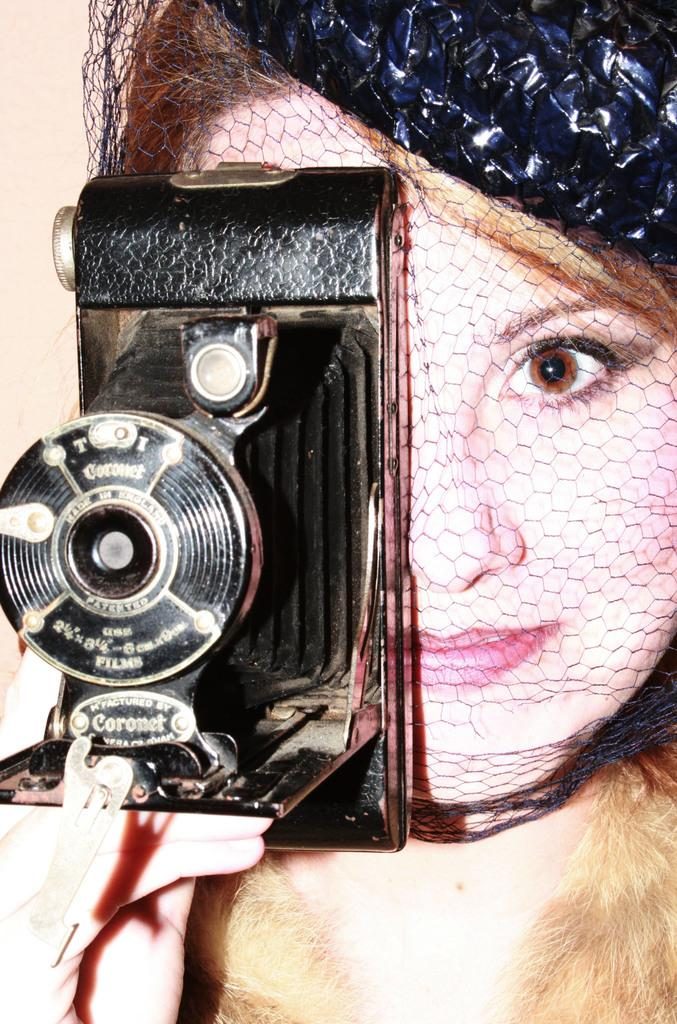Who is the main subject in the image? There is a lady in the image. What is the lady holding in her right hand? The lady is holding a camera in her right hand. What is the lady doing with her right eye? The lady is covering her right eye. What type of knife is the lady using to calculate payments in the image? There is no knife or calculator present in the image, and the lady is not making any payments. 